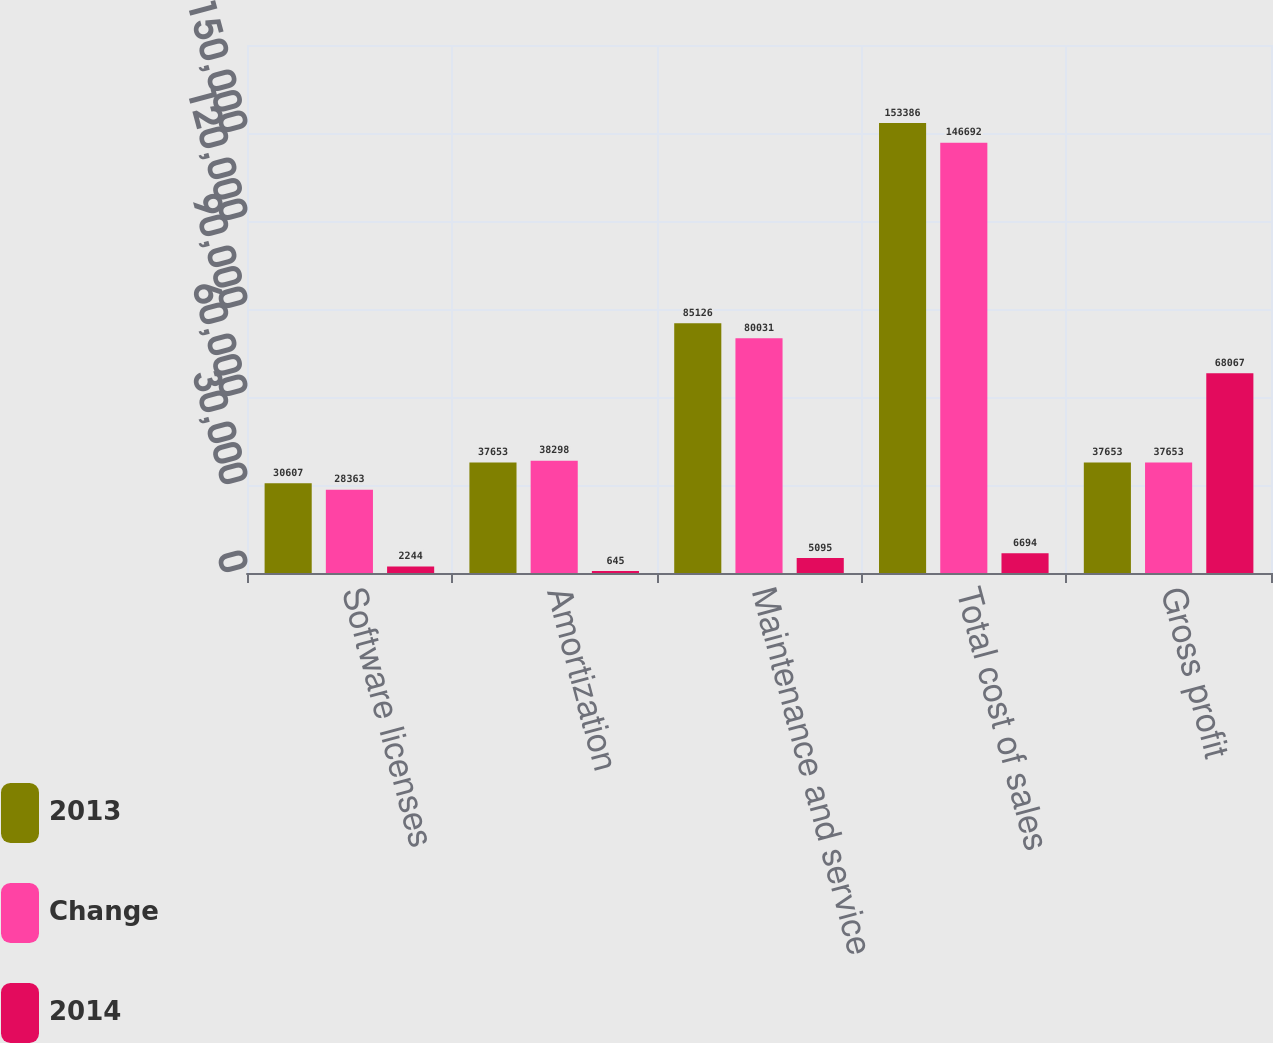Convert chart to OTSL. <chart><loc_0><loc_0><loc_500><loc_500><stacked_bar_chart><ecel><fcel>Software licenses<fcel>Amortization<fcel>Maintenance and service<fcel>Total cost of sales<fcel>Gross profit<nl><fcel>2013<fcel>30607<fcel>37653<fcel>85126<fcel>153386<fcel>37653<nl><fcel>Change<fcel>28363<fcel>38298<fcel>80031<fcel>146692<fcel>37653<nl><fcel>2014<fcel>2244<fcel>645<fcel>5095<fcel>6694<fcel>68067<nl></chart> 